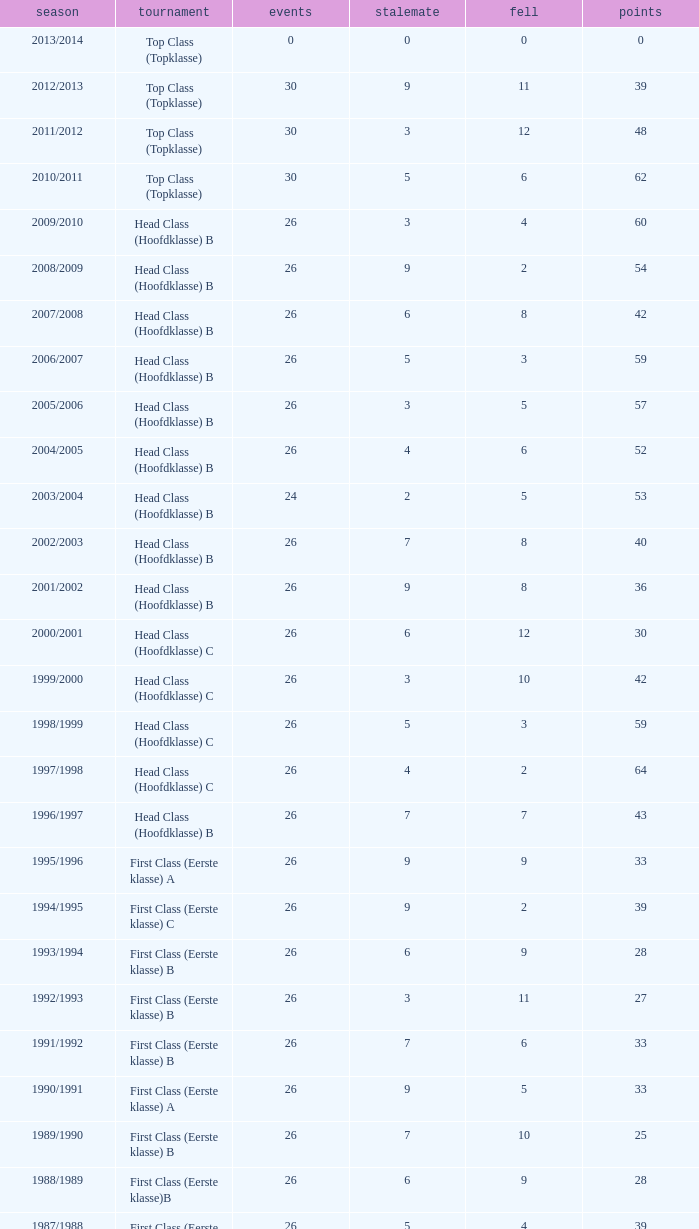What is the total number of matches with a loss less than 5 in the 2008/2009 season and has a draw larger than 9? 0.0. 